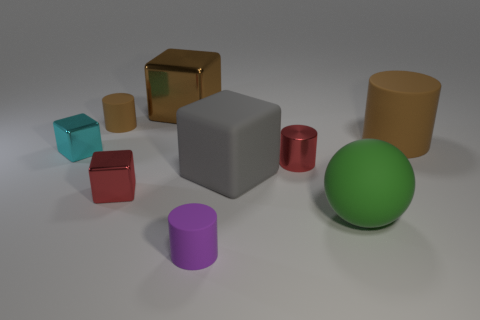What material is the tiny block that is the same color as the metallic cylinder?
Give a very brief answer. Metal. What number of metal blocks have the same color as the small metallic cylinder?
Ensure brevity in your answer.  1. Are there fewer large brown rubber cylinders than green metal cylinders?
Your response must be concise. No. Do the cyan thing and the small red cube have the same material?
Ensure brevity in your answer.  Yes. What number of other objects are there of the same size as the purple matte object?
Make the answer very short. 4. The small matte thing that is to the right of the big thing left of the small purple rubber thing is what color?
Provide a succinct answer. Purple. How many other things are there of the same shape as the green rubber object?
Provide a succinct answer. 0. Are there any green objects made of the same material as the red cube?
Ensure brevity in your answer.  No. What is the material of the red cylinder that is the same size as the cyan block?
Offer a very short reply. Metal. The large cube behind the small matte thing that is left of the large brown object to the left of the big brown matte thing is what color?
Ensure brevity in your answer.  Brown. 